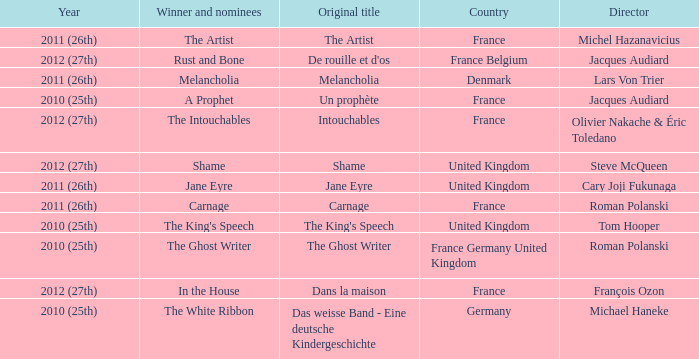What was the original title for the king's speech? The King's Speech. Parse the table in full. {'header': ['Year', 'Winner and nominees', 'Original title', 'Country', 'Director'], 'rows': [['2011 (26th)', 'The Artist', 'The Artist', 'France', 'Michel Hazanavicius'], ['2012 (27th)', 'Rust and Bone', "De rouille et d'os", 'France Belgium', 'Jacques Audiard'], ['2011 (26th)', 'Melancholia', 'Melancholia', 'Denmark', 'Lars Von Trier'], ['2010 (25th)', 'A Prophet', 'Un prophète', 'France', 'Jacques Audiard'], ['2012 (27th)', 'The Intouchables', 'Intouchables', 'France', 'Olivier Nakache & Éric Toledano'], ['2012 (27th)', 'Shame', 'Shame', 'United Kingdom', 'Steve McQueen'], ['2011 (26th)', 'Jane Eyre', 'Jane Eyre', 'United Kingdom', 'Cary Joji Fukunaga'], ['2011 (26th)', 'Carnage', 'Carnage', 'France', 'Roman Polanski'], ['2010 (25th)', "The King's Speech", "The King's Speech", 'United Kingdom', 'Tom Hooper'], ['2010 (25th)', 'The Ghost Writer', 'The Ghost Writer', 'France Germany United Kingdom', 'Roman Polanski'], ['2012 (27th)', 'In the House', 'Dans la maison', 'France', 'François Ozon'], ['2010 (25th)', 'The White Ribbon', 'Das weisse Band - Eine deutsche Kindergeschichte', 'Germany', 'Michael Haneke']]} 